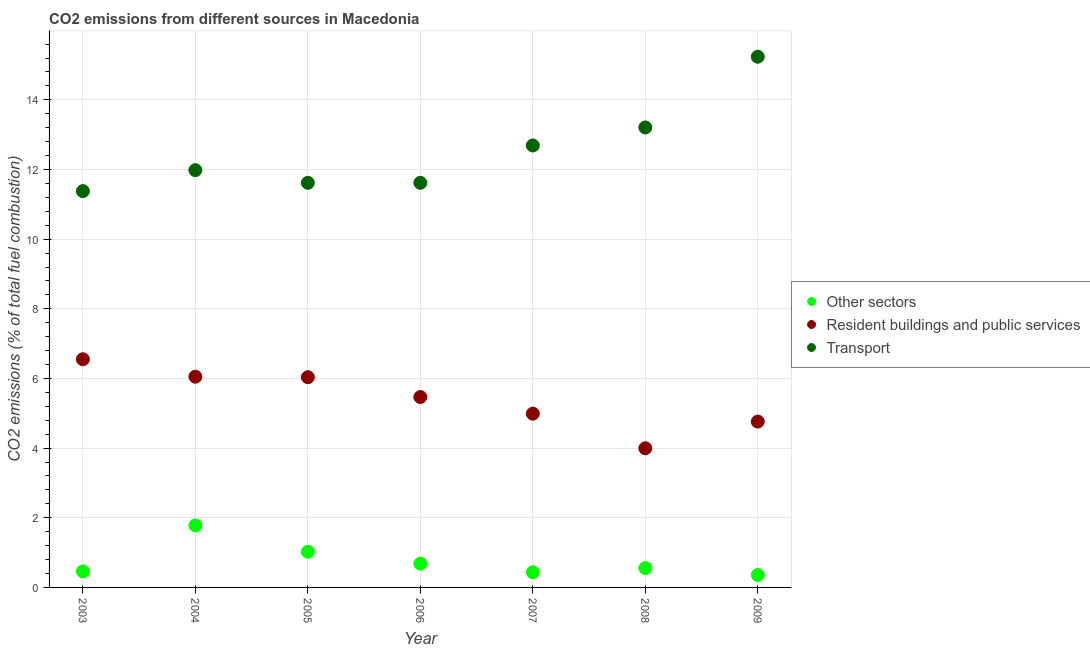Is the number of dotlines equal to the number of legend labels?
Your answer should be compact. Yes. What is the percentage of co2 emissions from transport in 2009?
Give a very brief answer. 15.24. Across all years, what is the maximum percentage of co2 emissions from transport?
Offer a terse response. 15.24. Across all years, what is the minimum percentage of co2 emissions from other sectors?
Provide a short and direct response. 0.36. In which year was the percentage of co2 emissions from other sectors maximum?
Your answer should be very brief. 2004. In which year was the percentage of co2 emissions from resident buildings and public services minimum?
Provide a succinct answer. 2008. What is the total percentage of co2 emissions from transport in the graph?
Your response must be concise. 87.73. What is the difference between the percentage of co2 emissions from resident buildings and public services in 2005 and that in 2007?
Ensure brevity in your answer.  1.05. What is the difference between the percentage of co2 emissions from resident buildings and public services in 2003 and the percentage of co2 emissions from transport in 2004?
Make the answer very short. -5.43. What is the average percentage of co2 emissions from other sectors per year?
Give a very brief answer. 0.76. In the year 2007, what is the difference between the percentage of co2 emissions from transport and percentage of co2 emissions from other sectors?
Your answer should be very brief. 12.26. What is the ratio of the percentage of co2 emissions from other sectors in 2004 to that in 2007?
Ensure brevity in your answer.  4.1. Is the percentage of co2 emissions from resident buildings and public services in 2005 less than that in 2009?
Offer a terse response. No. What is the difference between the highest and the second highest percentage of co2 emissions from other sectors?
Offer a terse response. 0.75. What is the difference between the highest and the lowest percentage of co2 emissions from resident buildings and public services?
Your answer should be compact. 2.56. In how many years, is the percentage of co2 emissions from resident buildings and public services greater than the average percentage of co2 emissions from resident buildings and public services taken over all years?
Make the answer very short. 4. Is it the case that in every year, the sum of the percentage of co2 emissions from other sectors and percentage of co2 emissions from resident buildings and public services is greater than the percentage of co2 emissions from transport?
Your response must be concise. No. Does the percentage of co2 emissions from resident buildings and public services monotonically increase over the years?
Your answer should be very brief. No. How many years are there in the graph?
Your response must be concise. 7. Are the values on the major ticks of Y-axis written in scientific E-notation?
Keep it short and to the point. No. Does the graph contain grids?
Ensure brevity in your answer.  Yes. How are the legend labels stacked?
Offer a very short reply. Vertical. What is the title of the graph?
Provide a succinct answer. CO2 emissions from different sources in Macedonia. Does "Transport equipments" appear as one of the legend labels in the graph?
Provide a short and direct response. No. What is the label or title of the X-axis?
Offer a terse response. Year. What is the label or title of the Y-axis?
Your answer should be compact. CO2 emissions (% of total fuel combustion). What is the CO2 emissions (% of total fuel combustion) in Other sectors in 2003?
Your answer should be compact. 0.46. What is the CO2 emissions (% of total fuel combustion) in Resident buildings and public services in 2003?
Your response must be concise. 6.55. What is the CO2 emissions (% of total fuel combustion) of Transport in 2003?
Your answer should be compact. 11.38. What is the CO2 emissions (% of total fuel combustion) of Other sectors in 2004?
Your response must be concise. 1.78. What is the CO2 emissions (% of total fuel combustion) of Resident buildings and public services in 2004?
Your answer should be very brief. 6.05. What is the CO2 emissions (% of total fuel combustion) in Transport in 2004?
Your response must be concise. 11.98. What is the CO2 emissions (% of total fuel combustion) in Other sectors in 2005?
Give a very brief answer. 1.03. What is the CO2 emissions (% of total fuel combustion) of Resident buildings and public services in 2005?
Make the answer very short. 6.04. What is the CO2 emissions (% of total fuel combustion) in Transport in 2005?
Ensure brevity in your answer.  11.62. What is the CO2 emissions (% of total fuel combustion) of Other sectors in 2006?
Ensure brevity in your answer.  0.68. What is the CO2 emissions (% of total fuel combustion) of Resident buildings and public services in 2006?
Your answer should be compact. 5.47. What is the CO2 emissions (% of total fuel combustion) of Transport in 2006?
Ensure brevity in your answer.  11.62. What is the CO2 emissions (% of total fuel combustion) of Other sectors in 2007?
Ensure brevity in your answer.  0.43. What is the CO2 emissions (% of total fuel combustion) of Resident buildings and public services in 2007?
Provide a succinct answer. 4.99. What is the CO2 emissions (% of total fuel combustion) in Transport in 2007?
Offer a very short reply. 12.69. What is the CO2 emissions (% of total fuel combustion) of Other sectors in 2008?
Ensure brevity in your answer.  0.55. What is the CO2 emissions (% of total fuel combustion) in Resident buildings and public services in 2008?
Provide a succinct answer. 4. What is the CO2 emissions (% of total fuel combustion) of Transport in 2008?
Make the answer very short. 13.21. What is the CO2 emissions (% of total fuel combustion) of Other sectors in 2009?
Make the answer very short. 0.36. What is the CO2 emissions (% of total fuel combustion) of Resident buildings and public services in 2009?
Make the answer very short. 4.76. What is the CO2 emissions (% of total fuel combustion) in Transport in 2009?
Keep it short and to the point. 15.24. Across all years, what is the maximum CO2 emissions (% of total fuel combustion) of Other sectors?
Offer a terse response. 1.78. Across all years, what is the maximum CO2 emissions (% of total fuel combustion) of Resident buildings and public services?
Your answer should be compact. 6.55. Across all years, what is the maximum CO2 emissions (% of total fuel combustion) of Transport?
Ensure brevity in your answer.  15.24. Across all years, what is the minimum CO2 emissions (% of total fuel combustion) in Other sectors?
Your response must be concise. 0.36. Across all years, what is the minimum CO2 emissions (% of total fuel combustion) in Resident buildings and public services?
Keep it short and to the point. 4. Across all years, what is the minimum CO2 emissions (% of total fuel combustion) of Transport?
Ensure brevity in your answer.  11.38. What is the total CO2 emissions (% of total fuel combustion) of Other sectors in the graph?
Keep it short and to the point. 5.29. What is the total CO2 emissions (% of total fuel combustion) of Resident buildings and public services in the graph?
Give a very brief answer. 37.85. What is the total CO2 emissions (% of total fuel combustion) of Transport in the graph?
Offer a very short reply. 87.73. What is the difference between the CO2 emissions (% of total fuel combustion) of Other sectors in 2003 and that in 2004?
Your answer should be compact. -1.32. What is the difference between the CO2 emissions (% of total fuel combustion) of Resident buildings and public services in 2003 and that in 2004?
Your answer should be very brief. 0.5. What is the difference between the CO2 emissions (% of total fuel combustion) in Transport in 2003 and that in 2004?
Your answer should be very brief. -0.6. What is the difference between the CO2 emissions (% of total fuel combustion) of Other sectors in 2003 and that in 2005?
Ensure brevity in your answer.  -0.57. What is the difference between the CO2 emissions (% of total fuel combustion) of Resident buildings and public services in 2003 and that in 2005?
Make the answer very short. 0.52. What is the difference between the CO2 emissions (% of total fuel combustion) of Transport in 2003 and that in 2005?
Keep it short and to the point. -0.24. What is the difference between the CO2 emissions (% of total fuel combustion) of Other sectors in 2003 and that in 2006?
Provide a succinct answer. -0.22. What is the difference between the CO2 emissions (% of total fuel combustion) in Resident buildings and public services in 2003 and that in 2006?
Give a very brief answer. 1.08. What is the difference between the CO2 emissions (% of total fuel combustion) in Transport in 2003 and that in 2006?
Provide a short and direct response. -0.24. What is the difference between the CO2 emissions (% of total fuel combustion) of Other sectors in 2003 and that in 2007?
Provide a succinct answer. 0.03. What is the difference between the CO2 emissions (% of total fuel combustion) in Resident buildings and public services in 2003 and that in 2007?
Make the answer very short. 1.56. What is the difference between the CO2 emissions (% of total fuel combustion) in Transport in 2003 and that in 2007?
Give a very brief answer. -1.31. What is the difference between the CO2 emissions (% of total fuel combustion) in Other sectors in 2003 and that in 2008?
Your answer should be compact. -0.1. What is the difference between the CO2 emissions (% of total fuel combustion) of Resident buildings and public services in 2003 and that in 2008?
Keep it short and to the point. 2.56. What is the difference between the CO2 emissions (% of total fuel combustion) of Transport in 2003 and that in 2008?
Offer a very short reply. -1.83. What is the difference between the CO2 emissions (% of total fuel combustion) of Other sectors in 2003 and that in 2009?
Offer a very short reply. 0.1. What is the difference between the CO2 emissions (% of total fuel combustion) in Resident buildings and public services in 2003 and that in 2009?
Make the answer very short. 1.79. What is the difference between the CO2 emissions (% of total fuel combustion) of Transport in 2003 and that in 2009?
Your answer should be very brief. -3.86. What is the difference between the CO2 emissions (% of total fuel combustion) in Other sectors in 2004 and that in 2005?
Offer a terse response. 0.75. What is the difference between the CO2 emissions (% of total fuel combustion) in Resident buildings and public services in 2004 and that in 2005?
Your response must be concise. 0.01. What is the difference between the CO2 emissions (% of total fuel combustion) in Transport in 2004 and that in 2005?
Offer a terse response. 0.36. What is the difference between the CO2 emissions (% of total fuel combustion) of Other sectors in 2004 and that in 2006?
Provide a succinct answer. 1.1. What is the difference between the CO2 emissions (% of total fuel combustion) of Resident buildings and public services in 2004 and that in 2006?
Ensure brevity in your answer.  0.58. What is the difference between the CO2 emissions (% of total fuel combustion) of Transport in 2004 and that in 2006?
Ensure brevity in your answer.  0.36. What is the difference between the CO2 emissions (% of total fuel combustion) in Other sectors in 2004 and that in 2007?
Give a very brief answer. 1.35. What is the difference between the CO2 emissions (% of total fuel combustion) of Resident buildings and public services in 2004 and that in 2007?
Your answer should be compact. 1.06. What is the difference between the CO2 emissions (% of total fuel combustion) in Transport in 2004 and that in 2007?
Keep it short and to the point. -0.71. What is the difference between the CO2 emissions (% of total fuel combustion) in Other sectors in 2004 and that in 2008?
Offer a terse response. 1.22. What is the difference between the CO2 emissions (% of total fuel combustion) in Resident buildings and public services in 2004 and that in 2008?
Give a very brief answer. 2.05. What is the difference between the CO2 emissions (% of total fuel combustion) of Transport in 2004 and that in 2008?
Your response must be concise. -1.23. What is the difference between the CO2 emissions (% of total fuel combustion) in Other sectors in 2004 and that in 2009?
Your answer should be compact. 1.42. What is the difference between the CO2 emissions (% of total fuel combustion) in Resident buildings and public services in 2004 and that in 2009?
Offer a very short reply. 1.29. What is the difference between the CO2 emissions (% of total fuel combustion) of Transport in 2004 and that in 2009?
Your response must be concise. -3.26. What is the difference between the CO2 emissions (% of total fuel combustion) in Other sectors in 2005 and that in 2006?
Provide a succinct answer. 0.34. What is the difference between the CO2 emissions (% of total fuel combustion) of Resident buildings and public services in 2005 and that in 2006?
Make the answer very short. 0.57. What is the difference between the CO2 emissions (% of total fuel combustion) of Transport in 2005 and that in 2006?
Give a very brief answer. 0. What is the difference between the CO2 emissions (% of total fuel combustion) of Other sectors in 2005 and that in 2007?
Offer a very short reply. 0.59. What is the difference between the CO2 emissions (% of total fuel combustion) in Resident buildings and public services in 2005 and that in 2007?
Give a very brief answer. 1.05. What is the difference between the CO2 emissions (% of total fuel combustion) in Transport in 2005 and that in 2007?
Keep it short and to the point. -1.07. What is the difference between the CO2 emissions (% of total fuel combustion) of Other sectors in 2005 and that in 2008?
Give a very brief answer. 0.47. What is the difference between the CO2 emissions (% of total fuel combustion) of Resident buildings and public services in 2005 and that in 2008?
Offer a very short reply. 2.04. What is the difference between the CO2 emissions (% of total fuel combustion) of Transport in 2005 and that in 2008?
Make the answer very short. -1.59. What is the difference between the CO2 emissions (% of total fuel combustion) of Other sectors in 2005 and that in 2009?
Keep it short and to the point. 0.67. What is the difference between the CO2 emissions (% of total fuel combustion) in Resident buildings and public services in 2005 and that in 2009?
Make the answer very short. 1.27. What is the difference between the CO2 emissions (% of total fuel combustion) in Transport in 2005 and that in 2009?
Make the answer very short. -3.62. What is the difference between the CO2 emissions (% of total fuel combustion) in Other sectors in 2006 and that in 2007?
Make the answer very short. 0.25. What is the difference between the CO2 emissions (% of total fuel combustion) of Resident buildings and public services in 2006 and that in 2007?
Your answer should be very brief. 0.48. What is the difference between the CO2 emissions (% of total fuel combustion) of Transport in 2006 and that in 2007?
Your answer should be compact. -1.07. What is the difference between the CO2 emissions (% of total fuel combustion) in Other sectors in 2006 and that in 2008?
Ensure brevity in your answer.  0.13. What is the difference between the CO2 emissions (% of total fuel combustion) in Resident buildings and public services in 2006 and that in 2008?
Give a very brief answer. 1.47. What is the difference between the CO2 emissions (% of total fuel combustion) in Transport in 2006 and that in 2008?
Give a very brief answer. -1.59. What is the difference between the CO2 emissions (% of total fuel combustion) of Other sectors in 2006 and that in 2009?
Your answer should be compact. 0.33. What is the difference between the CO2 emissions (% of total fuel combustion) in Resident buildings and public services in 2006 and that in 2009?
Offer a very short reply. 0.71. What is the difference between the CO2 emissions (% of total fuel combustion) in Transport in 2006 and that in 2009?
Your answer should be compact. -3.62. What is the difference between the CO2 emissions (% of total fuel combustion) in Other sectors in 2007 and that in 2008?
Offer a very short reply. -0.12. What is the difference between the CO2 emissions (% of total fuel combustion) in Transport in 2007 and that in 2008?
Your response must be concise. -0.52. What is the difference between the CO2 emissions (% of total fuel combustion) in Other sectors in 2007 and that in 2009?
Offer a very short reply. 0.08. What is the difference between the CO2 emissions (% of total fuel combustion) in Resident buildings and public services in 2007 and that in 2009?
Offer a terse response. 0.23. What is the difference between the CO2 emissions (% of total fuel combustion) in Transport in 2007 and that in 2009?
Make the answer very short. -2.55. What is the difference between the CO2 emissions (% of total fuel combustion) of Other sectors in 2008 and that in 2009?
Your response must be concise. 0.2. What is the difference between the CO2 emissions (% of total fuel combustion) in Resident buildings and public services in 2008 and that in 2009?
Your answer should be very brief. -0.77. What is the difference between the CO2 emissions (% of total fuel combustion) of Transport in 2008 and that in 2009?
Your answer should be very brief. -2.03. What is the difference between the CO2 emissions (% of total fuel combustion) in Other sectors in 2003 and the CO2 emissions (% of total fuel combustion) in Resident buildings and public services in 2004?
Offer a terse response. -5.59. What is the difference between the CO2 emissions (% of total fuel combustion) in Other sectors in 2003 and the CO2 emissions (% of total fuel combustion) in Transport in 2004?
Your answer should be very brief. -11.52. What is the difference between the CO2 emissions (% of total fuel combustion) in Resident buildings and public services in 2003 and the CO2 emissions (% of total fuel combustion) in Transport in 2004?
Your response must be concise. -5.43. What is the difference between the CO2 emissions (% of total fuel combustion) of Other sectors in 2003 and the CO2 emissions (% of total fuel combustion) of Resident buildings and public services in 2005?
Offer a very short reply. -5.58. What is the difference between the CO2 emissions (% of total fuel combustion) in Other sectors in 2003 and the CO2 emissions (% of total fuel combustion) in Transport in 2005?
Give a very brief answer. -11.16. What is the difference between the CO2 emissions (% of total fuel combustion) in Resident buildings and public services in 2003 and the CO2 emissions (% of total fuel combustion) in Transport in 2005?
Make the answer very short. -5.07. What is the difference between the CO2 emissions (% of total fuel combustion) in Other sectors in 2003 and the CO2 emissions (% of total fuel combustion) in Resident buildings and public services in 2006?
Your answer should be compact. -5.01. What is the difference between the CO2 emissions (% of total fuel combustion) of Other sectors in 2003 and the CO2 emissions (% of total fuel combustion) of Transport in 2006?
Make the answer very short. -11.16. What is the difference between the CO2 emissions (% of total fuel combustion) of Resident buildings and public services in 2003 and the CO2 emissions (% of total fuel combustion) of Transport in 2006?
Your answer should be compact. -5.07. What is the difference between the CO2 emissions (% of total fuel combustion) of Other sectors in 2003 and the CO2 emissions (% of total fuel combustion) of Resident buildings and public services in 2007?
Provide a succinct answer. -4.53. What is the difference between the CO2 emissions (% of total fuel combustion) in Other sectors in 2003 and the CO2 emissions (% of total fuel combustion) in Transport in 2007?
Your answer should be very brief. -12.23. What is the difference between the CO2 emissions (% of total fuel combustion) of Resident buildings and public services in 2003 and the CO2 emissions (% of total fuel combustion) of Transport in 2007?
Offer a very short reply. -6.14. What is the difference between the CO2 emissions (% of total fuel combustion) in Other sectors in 2003 and the CO2 emissions (% of total fuel combustion) in Resident buildings and public services in 2008?
Make the answer very short. -3.54. What is the difference between the CO2 emissions (% of total fuel combustion) in Other sectors in 2003 and the CO2 emissions (% of total fuel combustion) in Transport in 2008?
Your response must be concise. -12.75. What is the difference between the CO2 emissions (% of total fuel combustion) of Resident buildings and public services in 2003 and the CO2 emissions (% of total fuel combustion) of Transport in 2008?
Your answer should be compact. -6.66. What is the difference between the CO2 emissions (% of total fuel combustion) of Other sectors in 2003 and the CO2 emissions (% of total fuel combustion) of Resident buildings and public services in 2009?
Your answer should be compact. -4.3. What is the difference between the CO2 emissions (% of total fuel combustion) of Other sectors in 2003 and the CO2 emissions (% of total fuel combustion) of Transport in 2009?
Your answer should be compact. -14.78. What is the difference between the CO2 emissions (% of total fuel combustion) of Resident buildings and public services in 2003 and the CO2 emissions (% of total fuel combustion) of Transport in 2009?
Your answer should be very brief. -8.69. What is the difference between the CO2 emissions (% of total fuel combustion) of Other sectors in 2004 and the CO2 emissions (% of total fuel combustion) of Resident buildings and public services in 2005?
Make the answer very short. -4.26. What is the difference between the CO2 emissions (% of total fuel combustion) in Other sectors in 2004 and the CO2 emissions (% of total fuel combustion) in Transport in 2005?
Offer a terse response. -9.84. What is the difference between the CO2 emissions (% of total fuel combustion) of Resident buildings and public services in 2004 and the CO2 emissions (% of total fuel combustion) of Transport in 2005?
Offer a very short reply. -5.57. What is the difference between the CO2 emissions (% of total fuel combustion) of Other sectors in 2004 and the CO2 emissions (% of total fuel combustion) of Resident buildings and public services in 2006?
Offer a terse response. -3.69. What is the difference between the CO2 emissions (% of total fuel combustion) in Other sectors in 2004 and the CO2 emissions (% of total fuel combustion) in Transport in 2006?
Provide a succinct answer. -9.84. What is the difference between the CO2 emissions (% of total fuel combustion) in Resident buildings and public services in 2004 and the CO2 emissions (% of total fuel combustion) in Transport in 2006?
Ensure brevity in your answer.  -5.57. What is the difference between the CO2 emissions (% of total fuel combustion) of Other sectors in 2004 and the CO2 emissions (% of total fuel combustion) of Resident buildings and public services in 2007?
Your answer should be very brief. -3.21. What is the difference between the CO2 emissions (% of total fuel combustion) of Other sectors in 2004 and the CO2 emissions (% of total fuel combustion) of Transport in 2007?
Your response must be concise. -10.91. What is the difference between the CO2 emissions (% of total fuel combustion) in Resident buildings and public services in 2004 and the CO2 emissions (% of total fuel combustion) in Transport in 2007?
Keep it short and to the point. -6.64. What is the difference between the CO2 emissions (% of total fuel combustion) in Other sectors in 2004 and the CO2 emissions (% of total fuel combustion) in Resident buildings and public services in 2008?
Your answer should be very brief. -2.22. What is the difference between the CO2 emissions (% of total fuel combustion) in Other sectors in 2004 and the CO2 emissions (% of total fuel combustion) in Transport in 2008?
Provide a short and direct response. -11.43. What is the difference between the CO2 emissions (% of total fuel combustion) of Resident buildings and public services in 2004 and the CO2 emissions (% of total fuel combustion) of Transport in 2008?
Keep it short and to the point. -7.16. What is the difference between the CO2 emissions (% of total fuel combustion) in Other sectors in 2004 and the CO2 emissions (% of total fuel combustion) in Resident buildings and public services in 2009?
Make the answer very short. -2.98. What is the difference between the CO2 emissions (% of total fuel combustion) of Other sectors in 2004 and the CO2 emissions (% of total fuel combustion) of Transport in 2009?
Provide a succinct answer. -13.46. What is the difference between the CO2 emissions (% of total fuel combustion) of Resident buildings and public services in 2004 and the CO2 emissions (% of total fuel combustion) of Transport in 2009?
Your answer should be very brief. -9.19. What is the difference between the CO2 emissions (% of total fuel combustion) of Other sectors in 2005 and the CO2 emissions (% of total fuel combustion) of Resident buildings and public services in 2006?
Offer a very short reply. -4.44. What is the difference between the CO2 emissions (% of total fuel combustion) of Other sectors in 2005 and the CO2 emissions (% of total fuel combustion) of Transport in 2006?
Your answer should be very brief. -10.59. What is the difference between the CO2 emissions (% of total fuel combustion) of Resident buildings and public services in 2005 and the CO2 emissions (% of total fuel combustion) of Transport in 2006?
Give a very brief answer. -5.58. What is the difference between the CO2 emissions (% of total fuel combustion) in Other sectors in 2005 and the CO2 emissions (% of total fuel combustion) in Resident buildings and public services in 2007?
Provide a succinct answer. -3.96. What is the difference between the CO2 emissions (% of total fuel combustion) of Other sectors in 2005 and the CO2 emissions (% of total fuel combustion) of Transport in 2007?
Make the answer very short. -11.66. What is the difference between the CO2 emissions (% of total fuel combustion) in Resident buildings and public services in 2005 and the CO2 emissions (% of total fuel combustion) in Transport in 2007?
Provide a short and direct response. -6.65. What is the difference between the CO2 emissions (% of total fuel combustion) in Other sectors in 2005 and the CO2 emissions (% of total fuel combustion) in Resident buildings and public services in 2008?
Provide a short and direct response. -2.97. What is the difference between the CO2 emissions (% of total fuel combustion) in Other sectors in 2005 and the CO2 emissions (% of total fuel combustion) in Transport in 2008?
Provide a succinct answer. -12.18. What is the difference between the CO2 emissions (% of total fuel combustion) of Resident buildings and public services in 2005 and the CO2 emissions (% of total fuel combustion) of Transport in 2008?
Ensure brevity in your answer.  -7.17. What is the difference between the CO2 emissions (% of total fuel combustion) of Other sectors in 2005 and the CO2 emissions (% of total fuel combustion) of Resident buildings and public services in 2009?
Your response must be concise. -3.74. What is the difference between the CO2 emissions (% of total fuel combustion) in Other sectors in 2005 and the CO2 emissions (% of total fuel combustion) in Transport in 2009?
Give a very brief answer. -14.21. What is the difference between the CO2 emissions (% of total fuel combustion) of Resident buildings and public services in 2005 and the CO2 emissions (% of total fuel combustion) of Transport in 2009?
Give a very brief answer. -9.2. What is the difference between the CO2 emissions (% of total fuel combustion) in Other sectors in 2006 and the CO2 emissions (% of total fuel combustion) in Resident buildings and public services in 2007?
Provide a succinct answer. -4.31. What is the difference between the CO2 emissions (% of total fuel combustion) in Other sectors in 2006 and the CO2 emissions (% of total fuel combustion) in Transport in 2007?
Your answer should be very brief. -12.01. What is the difference between the CO2 emissions (% of total fuel combustion) of Resident buildings and public services in 2006 and the CO2 emissions (% of total fuel combustion) of Transport in 2007?
Your response must be concise. -7.22. What is the difference between the CO2 emissions (% of total fuel combustion) of Other sectors in 2006 and the CO2 emissions (% of total fuel combustion) of Resident buildings and public services in 2008?
Keep it short and to the point. -3.31. What is the difference between the CO2 emissions (% of total fuel combustion) of Other sectors in 2006 and the CO2 emissions (% of total fuel combustion) of Transport in 2008?
Offer a very short reply. -12.52. What is the difference between the CO2 emissions (% of total fuel combustion) in Resident buildings and public services in 2006 and the CO2 emissions (% of total fuel combustion) in Transport in 2008?
Provide a short and direct response. -7.74. What is the difference between the CO2 emissions (% of total fuel combustion) in Other sectors in 2006 and the CO2 emissions (% of total fuel combustion) in Resident buildings and public services in 2009?
Your answer should be very brief. -4.08. What is the difference between the CO2 emissions (% of total fuel combustion) of Other sectors in 2006 and the CO2 emissions (% of total fuel combustion) of Transport in 2009?
Give a very brief answer. -14.55. What is the difference between the CO2 emissions (% of total fuel combustion) of Resident buildings and public services in 2006 and the CO2 emissions (% of total fuel combustion) of Transport in 2009?
Offer a very short reply. -9.77. What is the difference between the CO2 emissions (% of total fuel combustion) of Other sectors in 2007 and the CO2 emissions (% of total fuel combustion) of Resident buildings and public services in 2008?
Give a very brief answer. -3.56. What is the difference between the CO2 emissions (% of total fuel combustion) of Other sectors in 2007 and the CO2 emissions (% of total fuel combustion) of Transport in 2008?
Your response must be concise. -12.77. What is the difference between the CO2 emissions (% of total fuel combustion) in Resident buildings and public services in 2007 and the CO2 emissions (% of total fuel combustion) in Transport in 2008?
Give a very brief answer. -8.22. What is the difference between the CO2 emissions (% of total fuel combustion) in Other sectors in 2007 and the CO2 emissions (% of total fuel combustion) in Resident buildings and public services in 2009?
Provide a succinct answer. -4.33. What is the difference between the CO2 emissions (% of total fuel combustion) of Other sectors in 2007 and the CO2 emissions (% of total fuel combustion) of Transport in 2009?
Your answer should be very brief. -14.8. What is the difference between the CO2 emissions (% of total fuel combustion) in Resident buildings and public services in 2007 and the CO2 emissions (% of total fuel combustion) in Transport in 2009?
Offer a very short reply. -10.25. What is the difference between the CO2 emissions (% of total fuel combustion) in Other sectors in 2008 and the CO2 emissions (% of total fuel combustion) in Resident buildings and public services in 2009?
Offer a very short reply. -4.21. What is the difference between the CO2 emissions (% of total fuel combustion) in Other sectors in 2008 and the CO2 emissions (% of total fuel combustion) in Transport in 2009?
Your response must be concise. -14.68. What is the difference between the CO2 emissions (% of total fuel combustion) of Resident buildings and public services in 2008 and the CO2 emissions (% of total fuel combustion) of Transport in 2009?
Ensure brevity in your answer.  -11.24. What is the average CO2 emissions (% of total fuel combustion) in Other sectors per year?
Keep it short and to the point. 0.76. What is the average CO2 emissions (% of total fuel combustion) of Resident buildings and public services per year?
Provide a short and direct response. 5.41. What is the average CO2 emissions (% of total fuel combustion) of Transport per year?
Offer a very short reply. 12.53. In the year 2003, what is the difference between the CO2 emissions (% of total fuel combustion) of Other sectors and CO2 emissions (% of total fuel combustion) of Resident buildings and public services?
Offer a very short reply. -6.09. In the year 2003, what is the difference between the CO2 emissions (% of total fuel combustion) of Other sectors and CO2 emissions (% of total fuel combustion) of Transport?
Provide a succinct answer. -10.92. In the year 2003, what is the difference between the CO2 emissions (% of total fuel combustion) of Resident buildings and public services and CO2 emissions (% of total fuel combustion) of Transport?
Keep it short and to the point. -4.83. In the year 2004, what is the difference between the CO2 emissions (% of total fuel combustion) in Other sectors and CO2 emissions (% of total fuel combustion) in Resident buildings and public services?
Provide a short and direct response. -4.27. In the year 2004, what is the difference between the CO2 emissions (% of total fuel combustion) of Other sectors and CO2 emissions (% of total fuel combustion) of Transport?
Provide a succinct answer. -10.2. In the year 2004, what is the difference between the CO2 emissions (% of total fuel combustion) in Resident buildings and public services and CO2 emissions (% of total fuel combustion) in Transport?
Offer a terse response. -5.93. In the year 2005, what is the difference between the CO2 emissions (% of total fuel combustion) of Other sectors and CO2 emissions (% of total fuel combustion) of Resident buildings and public services?
Your answer should be very brief. -5.01. In the year 2005, what is the difference between the CO2 emissions (% of total fuel combustion) of Other sectors and CO2 emissions (% of total fuel combustion) of Transport?
Your answer should be compact. -10.59. In the year 2005, what is the difference between the CO2 emissions (% of total fuel combustion) in Resident buildings and public services and CO2 emissions (% of total fuel combustion) in Transport?
Your answer should be very brief. -5.58. In the year 2006, what is the difference between the CO2 emissions (% of total fuel combustion) of Other sectors and CO2 emissions (% of total fuel combustion) of Resident buildings and public services?
Make the answer very short. -4.78. In the year 2006, what is the difference between the CO2 emissions (% of total fuel combustion) in Other sectors and CO2 emissions (% of total fuel combustion) in Transport?
Provide a short and direct response. -10.93. In the year 2006, what is the difference between the CO2 emissions (% of total fuel combustion) in Resident buildings and public services and CO2 emissions (% of total fuel combustion) in Transport?
Give a very brief answer. -6.15. In the year 2007, what is the difference between the CO2 emissions (% of total fuel combustion) in Other sectors and CO2 emissions (% of total fuel combustion) in Resident buildings and public services?
Make the answer very short. -4.56. In the year 2007, what is the difference between the CO2 emissions (% of total fuel combustion) in Other sectors and CO2 emissions (% of total fuel combustion) in Transport?
Ensure brevity in your answer.  -12.26. In the year 2007, what is the difference between the CO2 emissions (% of total fuel combustion) of Resident buildings and public services and CO2 emissions (% of total fuel combustion) of Transport?
Provide a succinct answer. -7.7. In the year 2008, what is the difference between the CO2 emissions (% of total fuel combustion) of Other sectors and CO2 emissions (% of total fuel combustion) of Resident buildings and public services?
Provide a succinct answer. -3.44. In the year 2008, what is the difference between the CO2 emissions (% of total fuel combustion) in Other sectors and CO2 emissions (% of total fuel combustion) in Transport?
Your answer should be compact. -12.65. In the year 2008, what is the difference between the CO2 emissions (% of total fuel combustion) in Resident buildings and public services and CO2 emissions (% of total fuel combustion) in Transport?
Your answer should be very brief. -9.21. In the year 2009, what is the difference between the CO2 emissions (% of total fuel combustion) in Other sectors and CO2 emissions (% of total fuel combustion) in Resident buildings and public services?
Provide a succinct answer. -4.4. In the year 2009, what is the difference between the CO2 emissions (% of total fuel combustion) in Other sectors and CO2 emissions (% of total fuel combustion) in Transport?
Your answer should be compact. -14.88. In the year 2009, what is the difference between the CO2 emissions (% of total fuel combustion) of Resident buildings and public services and CO2 emissions (% of total fuel combustion) of Transport?
Offer a terse response. -10.48. What is the ratio of the CO2 emissions (% of total fuel combustion) in Other sectors in 2003 to that in 2004?
Give a very brief answer. 0.26. What is the ratio of the CO2 emissions (% of total fuel combustion) in Resident buildings and public services in 2003 to that in 2004?
Your answer should be very brief. 1.08. What is the ratio of the CO2 emissions (% of total fuel combustion) in Transport in 2003 to that in 2004?
Offer a terse response. 0.95. What is the ratio of the CO2 emissions (% of total fuel combustion) in Other sectors in 2003 to that in 2005?
Provide a short and direct response. 0.45. What is the ratio of the CO2 emissions (% of total fuel combustion) of Resident buildings and public services in 2003 to that in 2005?
Offer a terse response. 1.09. What is the ratio of the CO2 emissions (% of total fuel combustion) in Transport in 2003 to that in 2005?
Your response must be concise. 0.98. What is the ratio of the CO2 emissions (% of total fuel combustion) of Other sectors in 2003 to that in 2006?
Make the answer very short. 0.67. What is the ratio of the CO2 emissions (% of total fuel combustion) of Resident buildings and public services in 2003 to that in 2006?
Offer a terse response. 1.2. What is the ratio of the CO2 emissions (% of total fuel combustion) in Transport in 2003 to that in 2006?
Provide a succinct answer. 0.98. What is the ratio of the CO2 emissions (% of total fuel combustion) in Other sectors in 2003 to that in 2007?
Your answer should be compact. 1.06. What is the ratio of the CO2 emissions (% of total fuel combustion) in Resident buildings and public services in 2003 to that in 2007?
Provide a succinct answer. 1.31. What is the ratio of the CO2 emissions (% of total fuel combustion) of Transport in 2003 to that in 2007?
Your answer should be very brief. 0.9. What is the ratio of the CO2 emissions (% of total fuel combustion) in Other sectors in 2003 to that in 2008?
Your response must be concise. 0.83. What is the ratio of the CO2 emissions (% of total fuel combustion) of Resident buildings and public services in 2003 to that in 2008?
Make the answer very short. 1.64. What is the ratio of the CO2 emissions (% of total fuel combustion) in Transport in 2003 to that in 2008?
Give a very brief answer. 0.86. What is the ratio of the CO2 emissions (% of total fuel combustion) in Other sectors in 2003 to that in 2009?
Provide a short and direct response. 1.29. What is the ratio of the CO2 emissions (% of total fuel combustion) in Resident buildings and public services in 2003 to that in 2009?
Your response must be concise. 1.38. What is the ratio of the CO2 emissions (% of total fuel combustion) in Transport in 2003 to that in 2009?
Your response must be concise. 0.75. What is the ratio of the CO2 emissions (% of total fuel combustion) of Other sectors in 2004 to that in 2005?
Your answer should be very brief. 1.74. What is the ratio of the CO2 emissions (% of total fuel combustion) in Resident buildings and public services in 2004 to that in 2005?
Provide a short and direct response. 1. What is the ratio of the CO2 emissions (% of total fuel combustion) in Transport in 2004 to that in 2005?
Your response must be concise. 1.03. What is the ratio of the CO2 emissions (% of total fuel combustion) in Other sectors in 2004 to that in 2006?
Ensure brevity in your answer.  2.6. What is the ratio of the CO2 emissions (% of total fuel combustion) in Resident buildings and public services in 2004 to that in 2006?
Offer a terse response. 1.11. What is the ratio of the CO2 emissions (% of total fuel combustion) of Transport in 2004 to that in 2006?
Offer a terse response. 1.03. What is the ratio of the CO2 emissions (% of total fuel combustion) in Other sectors in 2004 to that in 2007?
Offer a terse response. 4.1. What is the ratio of the CO2 emissions (% of total fuel combustion) of Resident buildings and public services in 2004 to that in 2007?
Offer a very short reply. 1.21. What is the ratio of the CO2 emissions (% of total fuel combustion) in Transport in 2004 to that in 2007?
Keep it short and to the point. 0.94. What is the ratio of the CO2 emissions (% of total fuel combustion) of Other sectors in 2004 to that in 2008?
Provide a succinct answer. 3.21. What is the ratio of the CO2 emissions (% of total fuel combustion) of Resident buildings and public services in 2004 to that in 2008?
Make the answer very short. 1.51. What is the ratio of the CO2 emissions (% of total fuel combustion) in Transport in 2004 to that in 2008?
Keep it short and to the point. 0.91. What is the ratio of the CO2 emissions (% of total fuel combustion) of Other sectors in 2004 to that in 2009?
Keep it short and to the point. 4.98. What is the ratio of the CO2 emissions (% of total fuel combustion) of Resident buildings and public services in 2004 to that in 2009?
Offer a terse response. 1.27. What is the ratio of the CO2 emissions (% of total fuel combustion) of Transport in 2004 to that in 2009?
Offer a very short reply. 0.79. What is the ratio of the CO2 emissions (% of total fuel combustion) in Other sectors in 2005 to that in 2006?
Provide a succinct answer. 1.5. What is the ratio of the CO2 emissions (% of total fuel combustion) in Resident buildings and public services in 2005 to that in 2006?
Provide a succinct answer. 1.1. What is the ratio of the CO2 emissions (% of total fuel combustion) in Other sectors in 2005 to that in 2007?
Give a very brief answer. 2.36. What is the ratio of the CO2 emissions (% of total fuel combustion) of Resident buildings and public services in 2005 to that in 2007?
Give a very brief answer. 1.21. What is the ratio of the CO2 emissions (% of total fuel combustion) of Transport in 2005 to that in 2007?
Keep it short and to the point. 0.92. What is the ratio of the CO2 emissions (% of total fuel combustion) of Other sectors in 2005 to that in 2008?
Your answer should be compact. 1.85. What is the ratio of the CO2 emissions (% of total fuel combustion) in Resident buildings and public services in 2005 to that in 2008?
Offer a very short reply. 1.51. What is the ratio of the CO2 emissions (% of total fuel combustion) of Transport in 2005 to that in 2008?
Your response must be concise. 0.88. What is the ratio of the CO2 emissions (% of total fuel combustion) of Other sectors in 2005 to that in 2009?
Provide a succinct answer. 2.87. What is the ratio of the CO2 emissions (% of total fuel combustion) of Resident buildings and public services in 2005 to that in 2009?
Offer a very short reply. 1.27. What is the ratio of the CO2 emissions (% of total fuel combustion) in Transport in 2005 to that in 2009?
Provide a succinct answer. 0.76. What is the ratio of the CO2 emissions (% of total fuel combustion) of Other sectors in 2006 to that in 2007?
Keep it short and to the point. 1.58. What is the ratio of the CO2 emissions (% of total fuel combustion) of Resident buildings and public services in 2006 to that in 2007?
Your answer should be compact. 1.1. What is the ratio of the CO2 emissions (% of total fuel combustion) in Transport in 2006 to that in 2007?
Ensure brevity in your answer.  0.92. What is the ratio of the CO2 emissions (% of total fuel combustion) of Other sectors in 2006 to that in 2008?
Your answer should be compact. 1.23. What is the ratio of the CO2 emissions (% of total fuel combustion) in Resident buildings and public services in 2006 to that in 2008?
Provide a succinct answer. 1.37. What is the ratio of the CO2 emissions (% of total fuel combustion) in Transport in 2006 to that in 2008?
Your answer should be very brief. 0.88. What is the ratio of the CO2 emissions (% of total fuel combustion) of Other sectors in 2006 to that in 2009?
Make the answer very short. 1.91. What is the ratio of the CO2 emissions (% of total fuel combustion) of Resident buildings and public services in 2006 to that in 2009?
Your answer should be very brief. 1.15. What is the ratio of the CO2 emissions (% of total fuel combustion) in Transport in 2006 to that in 2009?
Your answer should be very brief. 0.76. What is the ratio of the CO2 emissions (% of total fuel combustion) in Other sectors in 2007 to that in 2008?
Your answer should be compact. 0.78. What is the ratio of the CO2 emissions (% of total fuel combustion) in Resident buildings and public services in 2007 to that in 2008?
Keep it short and to the point. 1.25. What is the ratio of the CO2 emissions (% of total fuel combustion) of Transport in 2007 to that in 2008?
Keep it short and to the point. 0.96. What is the ratio of the CO2 emissions (% of total fuel combustion) in Other sectors in 2007 to that in 2009?
Ensure brevity in your answer.  1.21. What is the ratio of the CO2 emissions (% of total fuel combustion) of Resident buildings and public services in 2007 to that in 2009?
Your answer should be very brief. 1.05. What is the ratio of the CO2 emissions (% of total fuel combustion) in Transport in 2007 to that in 2009?
Your response must be concise. 0.83. What is the ratio of the CO2 emissions (% of total fuel combustion) of Other sectors in 2008 to that in 2009?
Provide a succinct answer. 1.55. What is the ratio of the CO2 emissions (% of total fuel combustion) in Resident buildings and public services in 2008 to that in 2009?
Provide a short and direct response. 0.84. What is the ratio of the CO2 emissions (% of total fuel combustion) in Transport in 2008 to that in 2009?
Your answer should be compact. 0.87. What is the difference between the highest and the second highest CO2 emissions (% of total fuel combustion) of Other sectors?
Your answer should be compact. 0.75. What is the difference between the highest and the second highest CO2 emissions (% of total fuel combustion) of Resident buildings and public services?
Make the answer very short. 0.5. What is the difference between the highest and the second highest CO2 emissions (% of total fuel combustion) in Transport?
Give a very brief answer. 2.03. What is the difference between the highest and the lowest CO2 emissions (% of total fuel combustion) in Other sectors?
Provide a short and direct response. 1.42. What is the difference between the highest and the lowest CO2 emissions (% of total fuel combustion) of Resident buildings and public services?
Give a very brief answer. 2.56. What is the difference between the highest and the lowest CO2 emissions (% of total fuel combustion) of Transport?
Your answer should be compact. 3.86. 